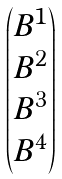Convert formula to latex. <formula><loc_0><loc_0><loc_500><loc_500>\begin{pmatrix} B ^ { 1 } \\ B ^ { 2 } \\ B ^ { 3 } \\ B ^ { 4 } \end{pmatrix}</formula> 